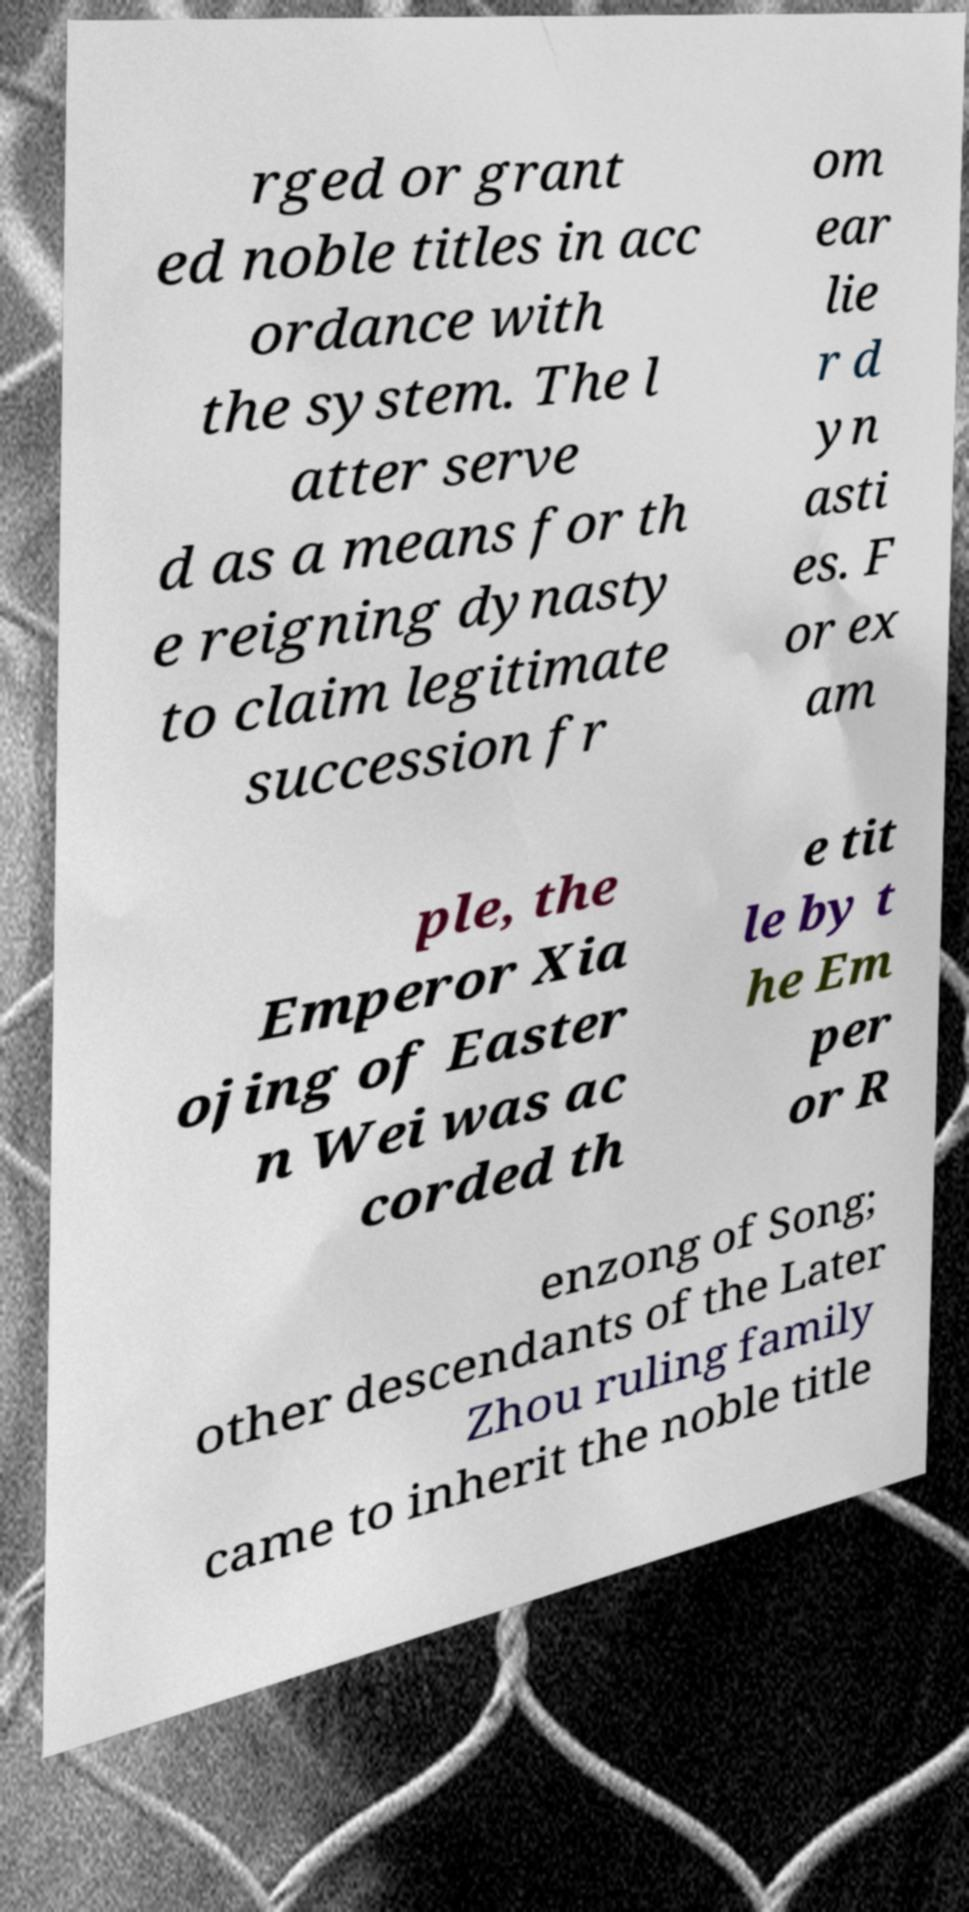Could you assist in decoding the text presented in this image and type it out clearly? rged or grant ed noble titles in acc ordance with the system. The l atter serve d as a means for th e reigning dynasty to claim legitimate succession fr om ear lie r d yn asti es. F or ex am ple, the Emperor Xia ojing of Easter n Wei was ac corded th e tit le by t he Em per or R enzong of Song; other descendants of the Later Zhou ruling family came to inherit the noble title 